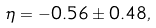Convert formula to latex. <formula><loc_0><loc_0><loc_500><loc_500>\eta = - 0 . 5 6 \pm 0 . 4 8 ,</formula> 